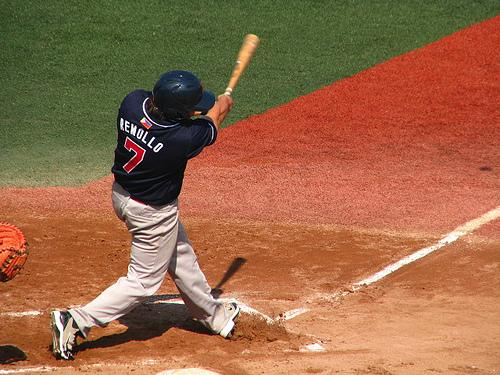How many different clothing items is the batter wearing? Name them briefly. The batter is wearing five different clothing items: a blue jersey with red number 7, white pants, blue helmet, white and blue shoes, and tan pants. Evaluate the sentiment of this image: is it intense, peaceful, or something else? The sentiment of this image is intense, as the baseball batter is swinging a bat with a focused look, which indicates determination and competition. Identify the player's jersey color and number, his activity, and the type of bat he is using. The player's jersey is blue with the red number 7 on it, he is swinging at a ball, and he is using a wooden bat. Please describe the features of the baseball field and any visible player-specific elements. The baseball field has a red clay dirt diamond surrounded by green grass, a visible part of home plate, and a white chalk baseline. A catcher's glove and the batter's shadow are visible. What is the main subject in this image and what action is he performing? Provide three details about his outfit. The main subject is a baseball batter swinging at a ball. He is wearing a blue jersey with a red 7, white pants and a blue helmet. Analyze the image and determine the main activity, briefly describing the playing area and any visible equipment. The main activity is baseball, with the playing area featuring a red clay dirt diamond surrounded by green grass, and visible equipment includes a wooden bat and a catcher's glove. Estimate how many objects are in the image, and mention some categories that these objects fall into. There are approximately 30 objects in the image, which can be categorized into attire (helmet, jersey, pants, shoes), equipment (bat, glove), and the playing field (home plate, diamond, grass). What is the most prominent object interaction in the image and what are the subjects that are interacting? The most prominent object interaction in the image is the baseball batter swinging a wooden bat, possibly interacting with the baseball. Describe the sport being played, the main player's outfit, and one action the player is doing. The sport is baseball, and the main player is wearing a blue jersey with the red number 7, white pants and a blue helmet, swinging a wooden bat. Describe the baseball player's outfit, including any numbers or logos featured on it. The baseball player's outfit includes a blue jersey with a red number 7 and his last name in white, white pants, and a blue helmet. Is the batter wearing a red jersey with a blue number 7? The batter is actually wearing a blue jersey with a red number 7. What is the color of the batter's helmet? Blue Identify the object that is partly visible behind the batter. Baseball catcher's glove Is the batter swinging a metallic bat in the image? The batter is actually swinging a wooden bat, not a metallic one. Which of the following options is an accurate depiction of the batter's shoes: a) Red and black, b) White and blue, c) Yellow and green? White and blue Are the batter's pants purple and covered with a unique pattern? The batter is wearing plain white or tan pants, not purple pants with patterns. Is the baseball diamond made of bright blue sand in this image? The baseball diamond is made of orange or red clay dirt, not bright blue sand. Can you see the catcher wearing a bright yellow glove behind the batter? The catcher's mitt is actually light brown, not bright yellow. What kind of pants is the batter wearing in the image? White/tan/grey pants Provide a short caption of the main action happening in the image. Baseball batter swinging at the ball Describe the shadow of the baseball glove in the image. The shadow is visible behind the batter Identify the material of the bat being used by the batter. Wood Does the batter have a green and purple helmet on his head? The batter's helmet is actually blue, not green and purple. Which of the following describes what can be seen on the player's jersey: a) name and number, b) baseball logo, c) random design? Name and number Are the surrounding grass in the image green or brown? Green In a short phrase, describe the type of field displayed in the image. Baseball field with green grass and red clay dirt What part of the baseball field can be seen in the image? Home plate and part of the third baseline What is the main activity the man in the image is involved in? Playing baseball Describe the jersey of the batter in the image. Blue with a red number 7 and the player's last name in white Describe the emotions visible on the batter's face in the given image. The batter's face is not visible due to the helmet What is the color of the number on the batter's jersey? Red How many players can clearly be seen in the image? Only the batter Which foot is the player's white and black shoe on? Right foot What is the number on the batter's jersey? 7 